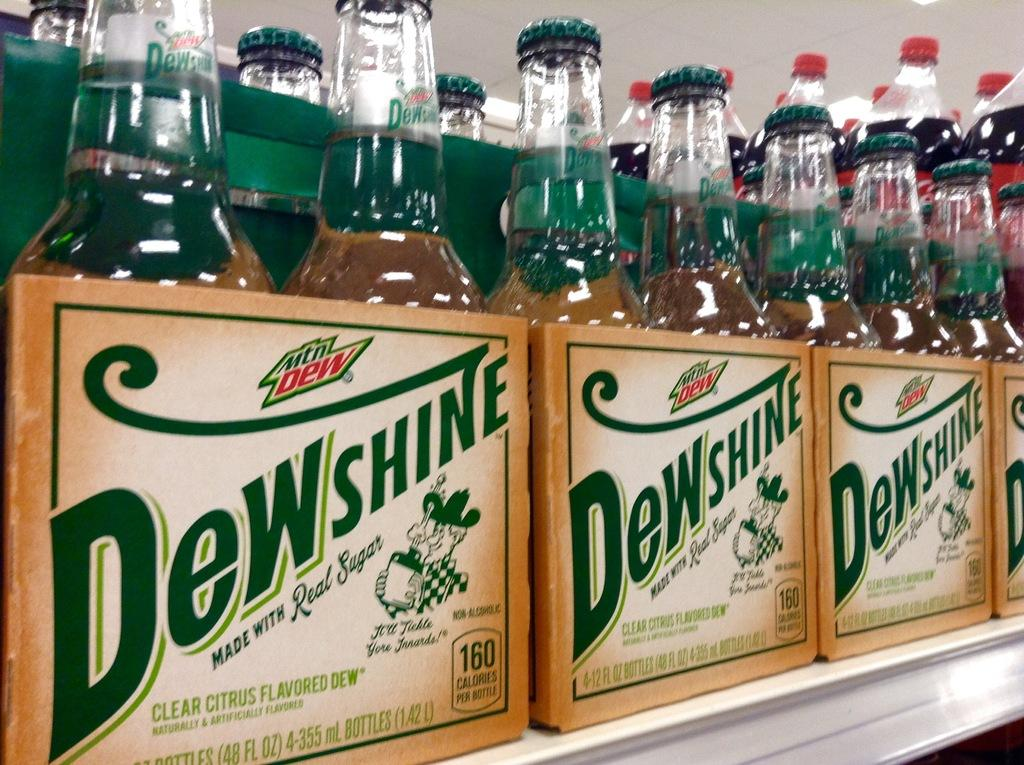<image>
Share a concise interpretation of the image provided. Several sixpacks of Dewshine in glass bottles on a shelf. 